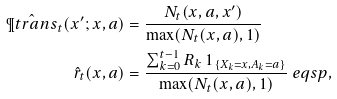<formula> <loc_0><loc_0><loc_500><loc_500>\hat { \P t r a n s } _ { t } ( x ^ { \prime } ; x , a ) & = \frac { N _ { t } ( x , a , x ^ { \prime } ) } { \max ( N _ { t } ( x , a ) , 1 ) } \\ \hat { r } _ { t } ( x , a ) & = \frac { \sum _ { k = 0 } ^ { t - 1 } R _ { k } \ 1 _ { \{ X _ { k } = x , A _ { k } = a \} } } { \max ( N _ { t } ( x , a ) , 1 ) } \ e q s p ,</formula> 